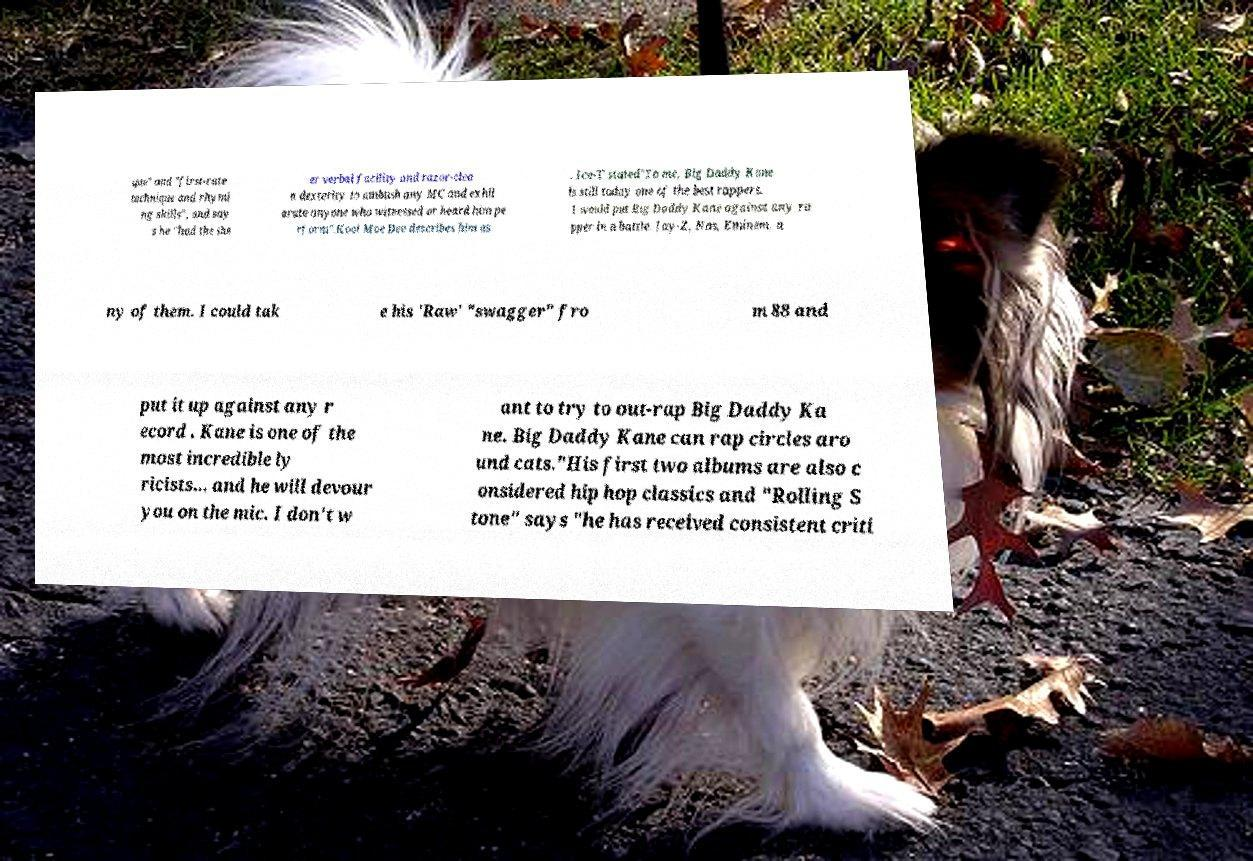Please read and relay the text visible in this image. What does it say? que" and "first-rate technique and rhymi ng skills", and say s he "had the she er verbal facility and razor-clea n dexterity to ambush any MC and exhil arate anyone who witnessed or heard him pe rform".Kool Moe Dee describes him as . Ice-T stated"To me, Big Daddy Kane is still today one of the best rappers. I would put Big Daddy Kane against any ra pper in a battle. Jay-Z, Nas, Eminem, a ny of them. I could tak e his 'Raw' "swagger" fro m 88 and put it up against any r ecord . Kane is one of the most incredible ly ricists… and he will devour you on the mic. I don't w ant to try to out-rap Big Daddy Ka ne. Big Daddy Kane can rap circles aro und cats."His first two albums are also c onsidered hip hop classics and "Rolling S tone" says "he has received consistent criti 